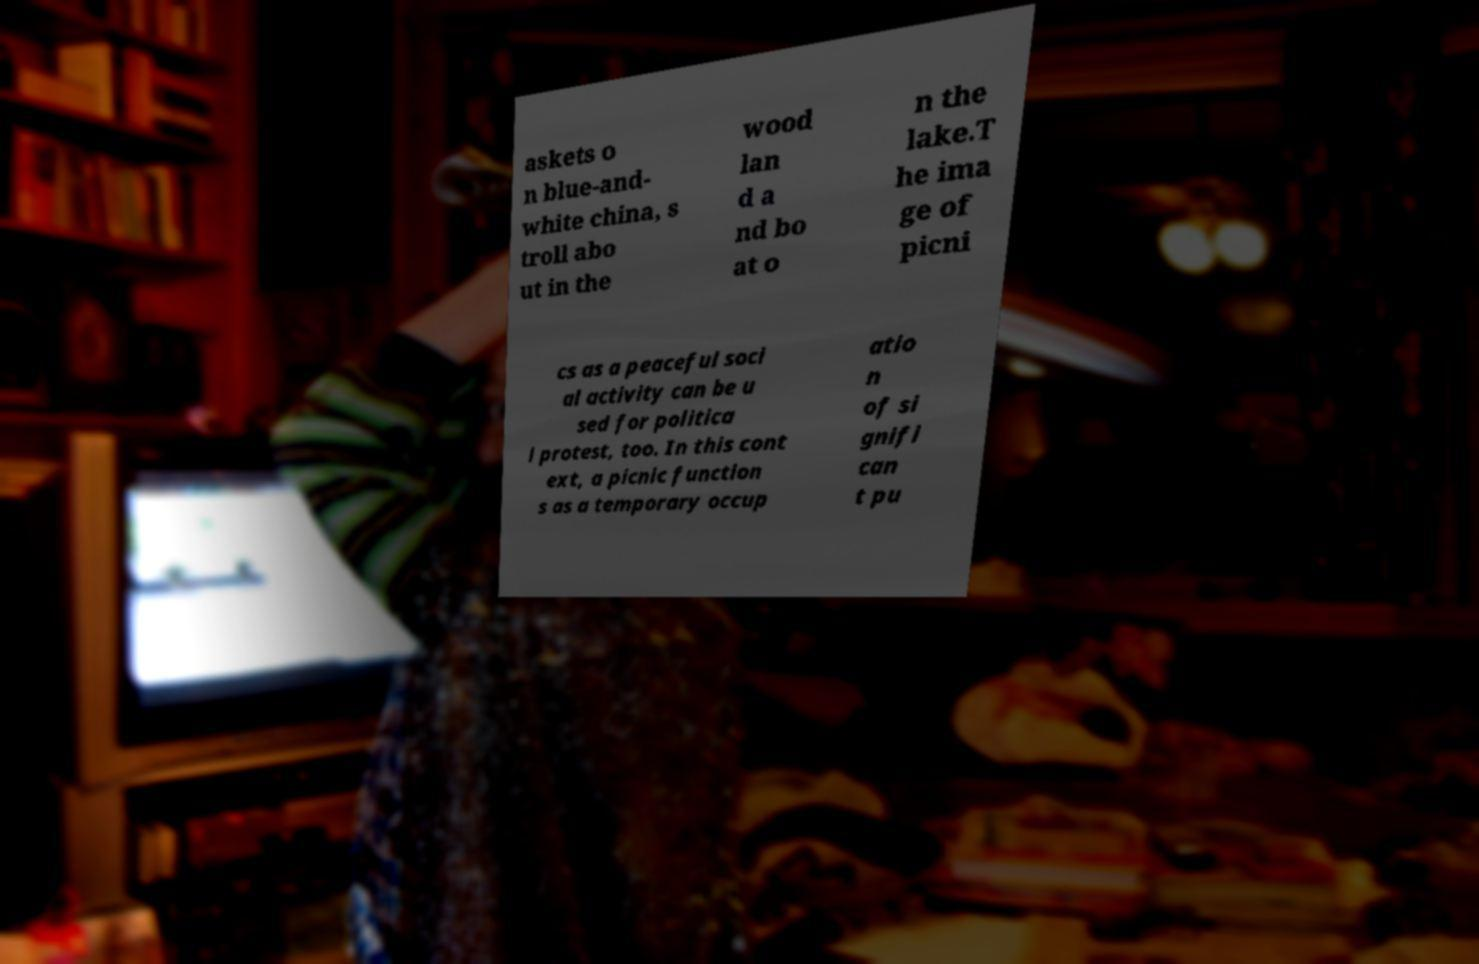For documentation purposes, I need the text within this image transcribed. Could you provide that? askets o n blue-and- white china, s troll abo ut in the wood lan d a nd bo at o n the lake.T he ima ge of picni cs as a peaceful soci al activity can be u sed for politica l protest, too. In this cont ext, a picnic function s as a temporary occup atio n of si gnifi can t pu 